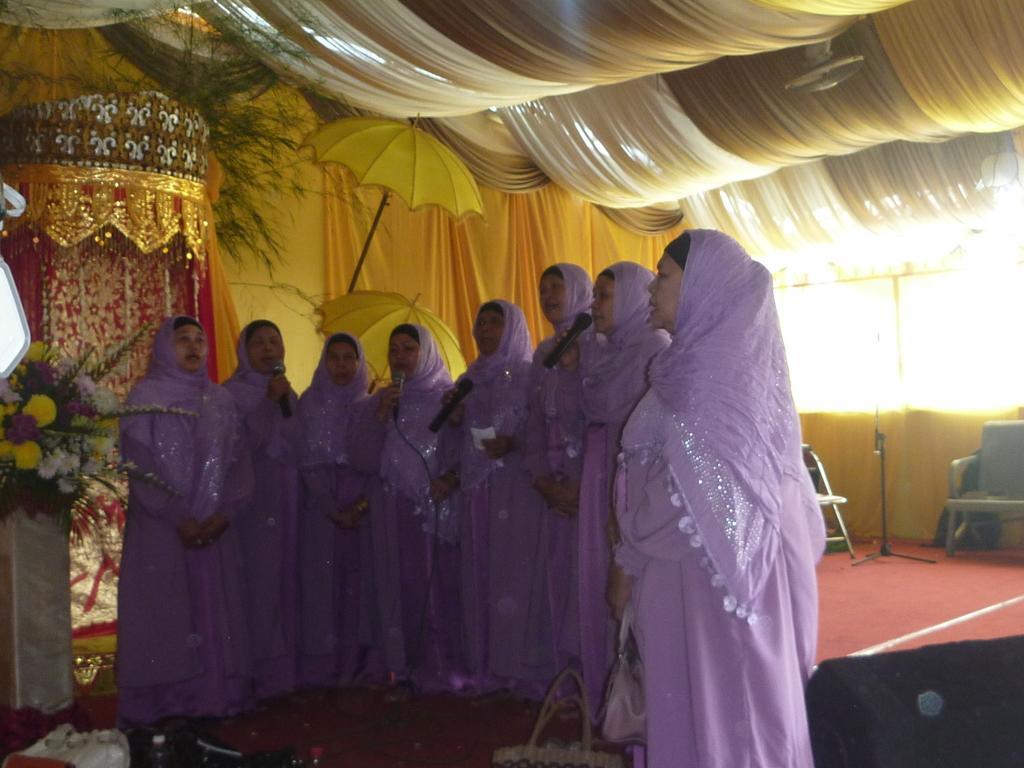Can you describe this image briefly? In this image, we can see some decors. There are group of people standing and wearing clothes. There are some persons holding mics with their hands. There is a chair on the right side of the image. There are umbrellas in the middle of the image. There are flowers on the left side of the image. 